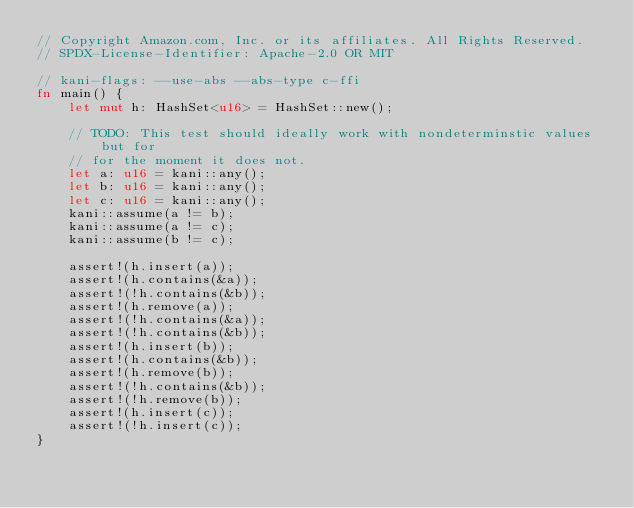Convert code to text. <code><loc_0><loc_0><loc_500><loc_500><_Rust_>// Copyright Amazon.com, Inc. or its affiliates. All Rights Reserved.
// SPDX-License-Identifier: Apache-2.0 OR MIT

// kani-flags: --use-abs --abs-type c-ffi
fn main() {
    let mut h: HashSet<u16> = HashSet::new();

    // TODO: This test should ideally work with nondeterminstic values but for
    // for the moment it does not.
    let a: u16 = kani::any();
    let b: u16 = kani::any();
    let c: u16 = kani::any();
    kani::assume(a != b);
    kani::assume(a != c);
    kani::assume(b != c);

    assert!(h.insert(a));
    assert!(h.contains(&a));
    assert!(!h.contains(&b));
    assert!(h.remove(a));
    assert!(!h.contains(&a));
    assert!(!h.contains(&b));
    assert!(h.insert(b));
    assert!(h.contains(&b));
    assert!(h.remove(b));
    assert!(!h.contains(&b));
    assert!(!h.remove(b));
    assert!(h.insert(c));
    assert!(!h.insert(c));
}
</code> 